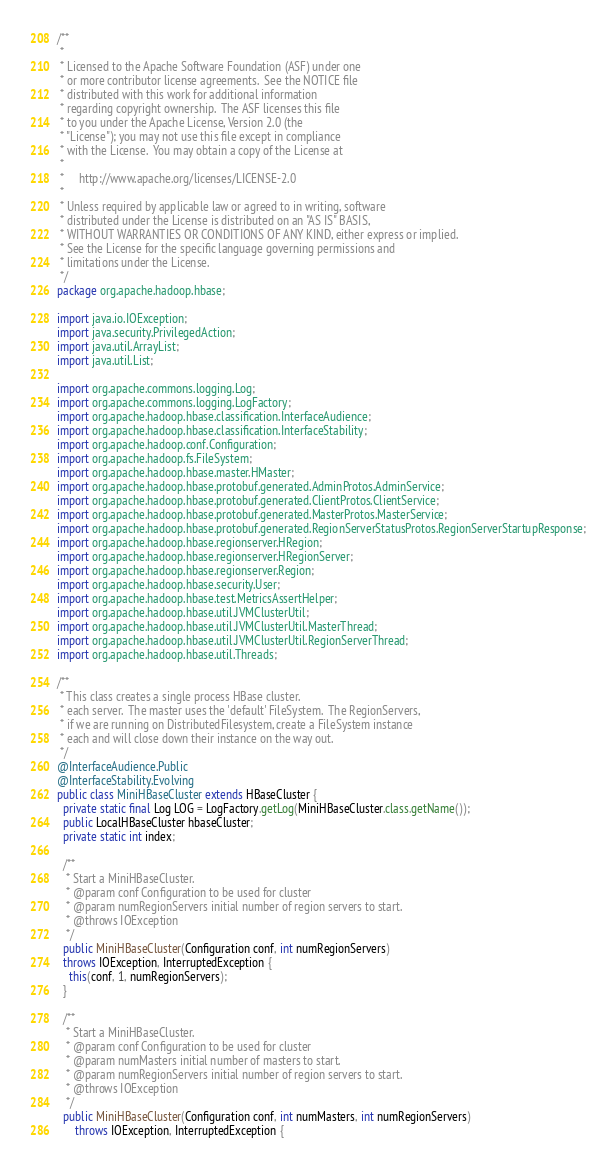<code> <loc_0><loc_0><loc_500><loc_500><_Java_>/**
 *
 * Licensed to the Apache Software Foundation (ASF) under one
 * or more contributor license agreements.  See the NOTICE file
 * distributed with this work for additional information
 * regarding copyright ownership.  The ASF licenses this file
 * to you under the Apache License, Version 2.0 (the
 * "License"); you may not use this file except in compliance
 * with the License.  You may obtain a copy of the License at
 *
 *     http://www.apache.org/licenses/LICENSE-2.0
 *
 * Unless required by applicable law or agreed to in writing, software
 * distributed under the License is distributed on an "AS IS" BASIS,
 * WITHOUT WARRANTIES OR CONDITIONS OF ANY KIND, either express or implied.
 * See the License for the specific language governing permissions and
 * limitations under the License.
 */
package org.apache.hadoop.hbase;

import java.io.IOException;
import java.security.PrivilegedAction;
import java.util.ArrayList;
import java.util.List;

import org.apache.commons.logging.Log;
import org.apache.commons.logging.LogFactory;
import org.apache.hadoop.hbase.classification.InterfaceAudience;
import org.apache.hadoop.hbase.classification.InterfaceStability;
import org.apache.hadoop.conf.Configuration;
import org.apache.hadoop.fs.FileSystem;
import org.apache.hadoop.hbase.master.HMaster;
import org.apache.hadoop.hbase.protobuf.generated.AdminProtos.AdminService;
import org.apache.hadoop.hbase.protobuf.generated.ClientProtos.ClientService;
import org.apache.hadoop.hbase.protobuf.generated.MasterProtos.MasterService;
import org.apache.hadoop.hbase.protobuf.generated.RegionServerStatusProtos.RegionServerStartupResponse;
import org.apache.hadoop.hbase.regionserver.HRegion;
import org.apache.hadoop.hbase.regionserver.HRegionServer;
import org.apache.hadoop.hbase.regionserver.Region;
import org.apache.hadoop.hbase.security.User;
import org.apache.hadoop.hbase.test.MetricsAssertHelper;
import org.apache.hadoop.hbase.util.JVMClusterUtil;
import org.apache.hadoop.hbase.util.JVMClusterUtil.MasterThread;
import org.apache.hadoop.hbase.util.JVMClusterUtil.RegionServerThread;
import org.apache.hadoop.hbase.util.Threads;

/**
 * This class creates a single process HBase cluster.
 * each server.  The master uses the 'default' FileSystem.  The RegionServers,
 * if we are running on DistributedFilesystem, create a FileSystem instance
 * each and will close down their instance on the way out.
 */
@InterfaceAudience.Public
@InterfaceStability.Evolving
public class MiniHBaseCluster extends HBaseCluster {
  private static final Log LOG = LogFactory.getLog(MiniHBaseCluster.class.getName());
  public LocalHBaseCluster hbaseCluster;
  private static int index;

  /**
   * Start a MiniHBaseCluster.
   * @param conf Configuration to be used for cluster
   * @param numRegionServers initial number of region servers to start.
   * @throws IOException
   */
  public MiniHBaseCluster(Configuration conf, int numRegionServers)
  throws IOException, InterruptedException {
    this(conf, 1, numRegionServers);
  }

  /**
   * Start a MiniHBaseCluster.
   * @param conf Configuration to be used for cluster
   * @param numMasters initial number of masters to start.
   * @param numRegionServers initial number of region servers to start.
   * @throws IOException
   */
  public MiniHBaseCluster(Configuration conf, int numMasters, int numRegionServers)
      throws IOException, InterruptedException {</code> 